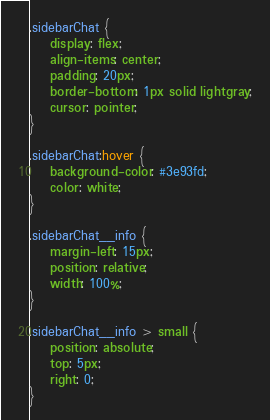Convert code to text. <code><loc_0><loc_0><loc_500><loc_500><_CSS_>.sidebarChat {
    display: flex;
    align-items: center;
    padding: 20px;
    border-bottom: 1px solid lightgray;
    cursor: pointer;
}

.sidebarChat:hover {
    background-color: #3e93fd;
    color: white;
}

.sidebarChat__info {
    margin-left: 15px;
    position: relative;
    width: 100%;
}

.sidebarChat__info > small {
    position: absolute;
    top: 5px;
    right: 0;
}</code> 